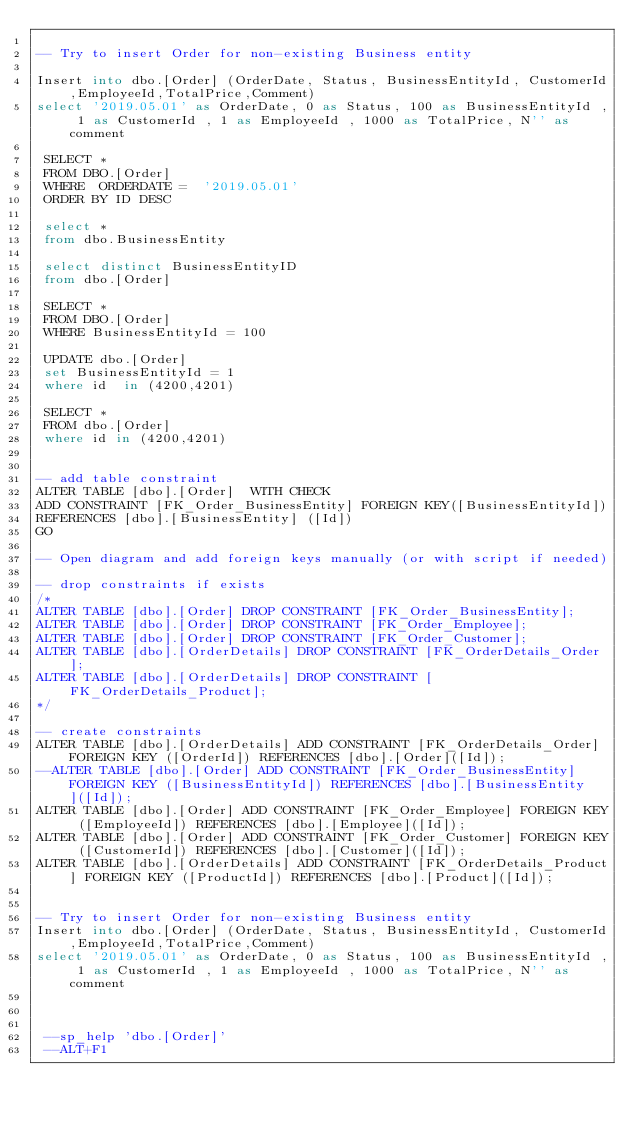Convert code to text. <code><loc_0><loc_0><loc_500><loc_500><_SQL_>
-- Try to insert Order for non-existing Business entity

Insert into dbo.[Order] (OrderDate, Status, BusinessEntityId, CustomerId,EmployeeId,TotalPrice,Comment)
select '2019.05.01' as OrderDate, 0 as Status, 100 as BusinessEntityId , 1 as CustomerId , 1 as EmployeeId , 1000 as TotalPrice, N'' as comment
 
 SELECT *
 FROM DBO.[Order]
 WHERE  ORDERDATE =  '2019.05.01'
 ORDER BY ID DESC

 select *
 from dbo.BusinessEntity

 select distinct BusinessEntityID
 from dbo.[Order]

 SELECT *
 FROM DBO.[Order]
 WHERE BusinessEntityId = 100

 UPDATE dbo.[Order]
 set BusinessEntityId = 1
 where id  in (4200,4201)

 SELECT *
 FROM dbo.[Order]
 where id in (4200,4201)


-- add table constraint
ALTER TABLE [dbo].[Order]  WITH CHECK 
ADD CONSTRAINT [FK_Order_BusinessEntity] FOREIGN KEY([BusinessEntityId])
REFERENCES [dbo].[BusinessEntity] ([Id])
GO

-- Open diagram and add foreign keys manually (or with script if needed)

-- drop constraints if exists
/*
ALTER TABLE [dbo].[Order] DROP CONSTRAINT [FK_Order_BusinessEntity];
ALTER TABLE [dbo].[Order] DROP CONSTRAINT [FK_Order_Employee];
ALTER TABLE [dbo].[Order] DROP CONSTRAINT [FK_Order_Customer];
ALTER TABLE [dbo].[OrderDetails] DROP CONSTRAINT [FK_OrderDetails_Order];
ALTER TABLE [dbo].[OrderDetails] DROP CONSTRAINT [FK_OrderDetails_Product];
*/

-- create constraints
ALTER TABLE [dbo].[OrderDetails] ADD CONSTRAINT [FK_OrderDetails_Order] FOREIGN KEY ([OrderId]) REFERENCES [dbo].[Order]([Id]);
--ALTER TABLE [dbo].[Order] ADD CONSTRAINT [FK_Order_BusinessEntity] FOREIGN KEY ([BusinessEntityId]) REFERENCES [dbo].[BusinessEntity]([Id]);
ALTER TABLE [dbo].[Order] ADD CONSTRAINT [FK_Order_Employee] FOREIGN KEY ([EmployeeId]) REFERENCES [dbo].[Employee]([Id]);
ALTER TABLE [dbo].[Order] ADD CONSTRAINT [FK_Order_Customer] FOREIGN KEY ([CustomerId]) REFERENCES [dbo].[Customer]([Id]);
ALTER TABLE [dbo].[OrderDetails] ADD CONSTRAINT [FK_OrderDetails_Product] FOREIGN KEY ([ProductId]) REFERENCES [dbo].[Product]([Id]);


-- Try to insert Order for non-existing Business entity
Insert into dbo.[Order] (OrderDate, Status, BusinessEntityId, CustomerId,EmployeeId,TotalPrice,Comment)
select '2019.05.01' as OrderDate, 0 as Status, 100 as BusinessEntityId , 1 as CustomerId , 1 as EmployeeId , 1000 as TotalPrice, N'' as comment
 


 --sp_help 'dbo.[Order]'
 --ALT+F1</code> 